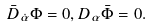Convert formula to latex. <formula><loc_0><loc_0><loc_500><loc_500>\bar { D } _ { \dot { \alpha } } \Phi = 0 , D _ { \alpha } \bar { \Phi } = 0 .</formula> 